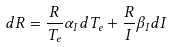<formula> <loc_0><loc_0><loc_500><loc_500>d R = \frac { R } { T _ { e } } \alpha _ { I } d T _ { e } + \frac { R } { I } \beta _ { I } d I</formula> 